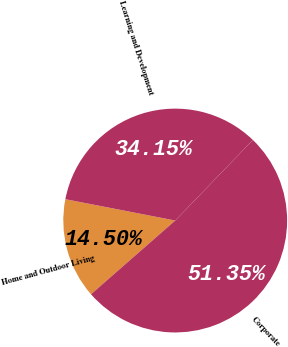Convert chart to OTSL. <chart><loc_0><loc_0><loc_500><loc_500><pie_chart><fcel>Home and Outdoor Living<fcel>Learning and Development<fcel>Corporate<nl><fcel>14.5%<fcel>34.15%<fcel>51.35%<nl></chart> 